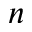Convert formula to latex. <formula><loc_0><loc_0><loc_500><loc_500>n</formula> 